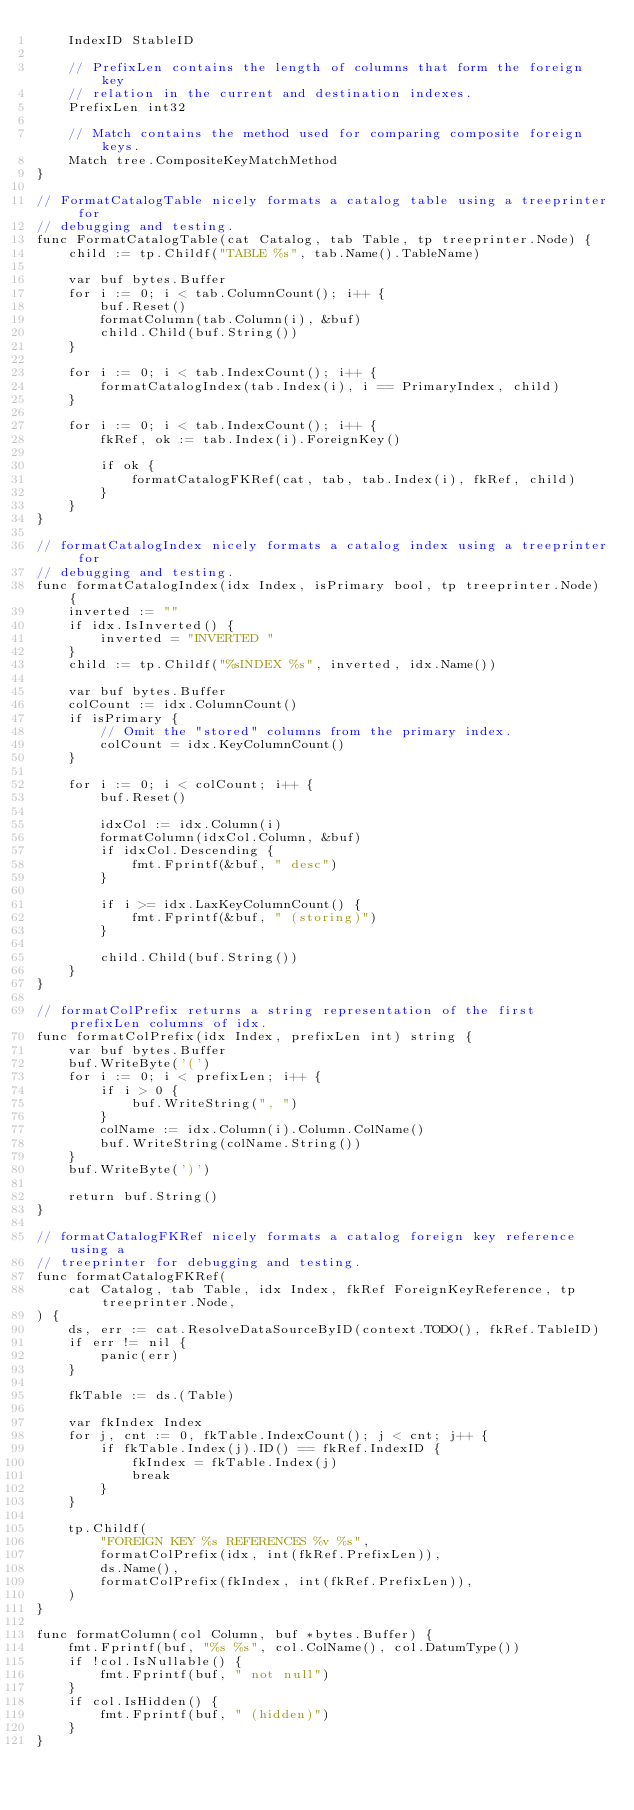Convert code to text. <code><loc_0><loc_0><loc_500><loc_500><_Go_>	IndexID StableID

	// PrefixLen contains the length of columns that form the foreign key
	// relation in the current and destination indexes.
	PrefixLen int32

	// Match contains the method used for comparing composite foreign keys.
	Match tree.CompositeKeyMatchMethod
}

// FormatCatalogTable nicely formats a catalog table using a treeprinter for
// debugging and testing.
func FormatCatalogTable(cat Catalog, tab Table, tp treeprinter.Node) {
	child := tp.Childf("TABLE %s", tab.Name().TableName)

	var buf bytes.Buffer
	for i := 0; i < tab.ColumnCount(); i++ {
		buf.Reset()
		formatColumn(tab.Column(i), &buf)
		child.Child(buf.String())
	}

	for i := 0; i < tab.IndexCount(); i++ {
		formatCatalogIndex(tab.Index(i), i == PrimaryIndex, child)
	}

	for i := 0; i < tab.IndexCount(); i++ {
		fkRef, ok := tab.Index(i).ForeignKey()

		if ok {
			formatCatalogFKRef(cat, tab, tab.Index(i), fkRef, child)
		}
	}
}

// formatCatalogIndex nicely formats a catalog index using a treeprinter for
// debugging and testing.
func formatCatalogIndex(idx Index, isPrimary bool, tp treeprinter.Node) {
	inverted := ""
	if idx.IsInverted() {
		inverted = "INVERTED "
	}
	child := tp.Childf("%sINDEX %s", inverted, idx.Name())

	var buf bytes.Buffer
	colCount := idx.ColumnCount()
	if isPrimary {
		// Omit the "stored" columns from the primary index.
		colCount = idx.KeyColumnCount()
	}

	for i := 0; i < colCount; i++ {
		buf.Reset()

		idxCol := idx.Column(i)
		formatColumn(idxCol.Column, &buf)
		if idxCol.Descending {
			fmt.Fprintf(&buf, " desc")
		}

		if i >= idx.LaxKeyColumnCount() {
			fmt.Fprintf(&buf, " (storing)")
		}

		child.Child(buf.String())
	}
}

// formatColPrefix returns a string representation of the first prefixLen columns of idx.
func formatColPrefix(idx Index, prefixLen int) string {
	var buf bytes.Buffer
	buf.WriteByte('(')
	for i := 0; i < prefixLen; i++ {
		if i > 0 {
			buf.WriteString(", ")
		}
		colName := idx.Column(i).Column.ColName()
		buf.WriteString(colName.String())
	}
	buf.WriteByte(')')

	return buf.String()
}

// formatCatalogFKRef nicely formats a catalog foreign key reference using a
// treeprinter for debugging and testing.
func formatCatalogFKRef(
	cat Catalog, tab Table, idx Index, fkRef ForeignKeyReference, tp treeprinter.Node,
) {
	ds, err := cat.ResolveDataSourceByID(context.TODO(), fkRef.TableID)
	if err != nil {
		panic(err)
	}

	fkTable := ds.(Table)

	var fkIndex Index
	for j, cnt := 0, fkTable.IndexCount(); j < cnt; j++ {
		if fkTable.Index(j).ID() == fkRef.IndexID {
			fkIndex = fkTable.Index(j)
			break
		}
	}

	tp.Childf(
		"FOREIGN KEY %s REFERENCES %v %s",
		formatColPrefix(idx, int(fkRef.PrefixLen)),
		ds.Name(),
		formatColPrefix(fkIndex, int(fkRef.PrefixLen)),
	)
}

func formatColumn(col Column, buf *bytes.Buffer) {
	fmt.Fprintf(buf, "%s %s", col.ColName(), col.DatumType())
	if !col.IsNullable() {
		fmt.Fprintf(buf, " not null")
	}
	if col.IsHidden() {
		fmt.Fprintf(buf, " (hidden)")
	}
}
</code> 